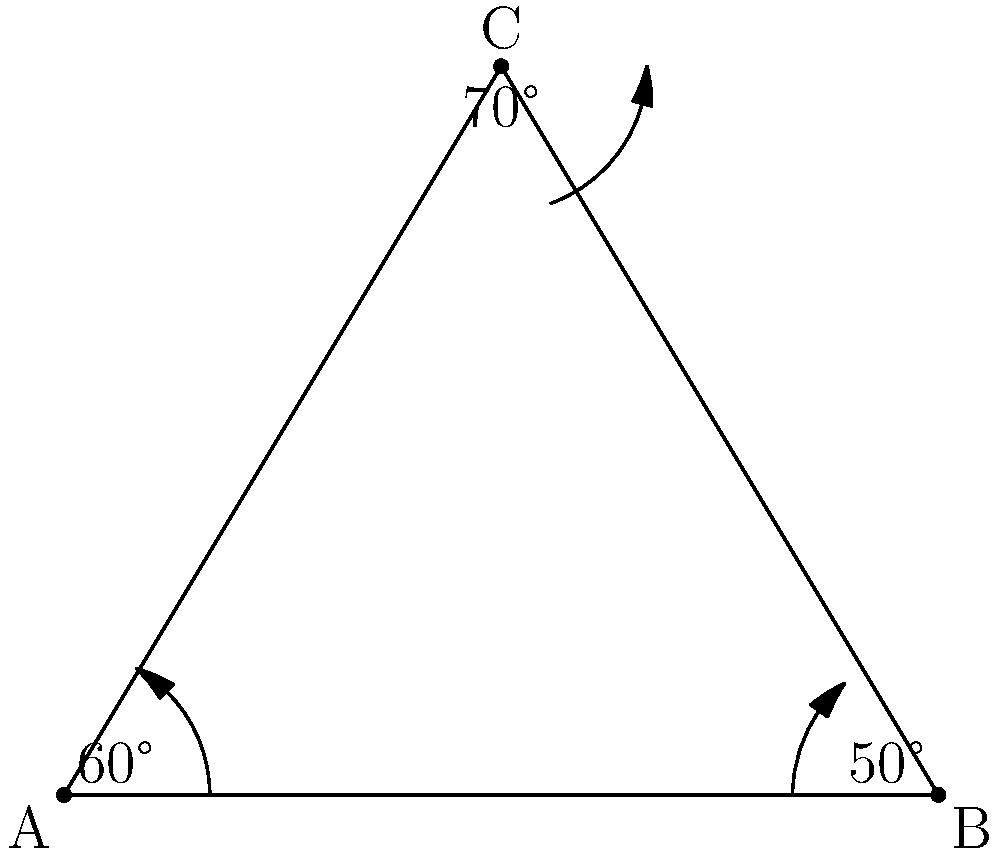In a theater production, three spotlights are positioned to form a triangle on stage. The angles between the spotlights are 60°, 50°, and 70°. If the distance between the two spotlights on the floor is 6 meters, what is the height of the third spotlight above the stage floor? Round your answer to the nearest centimeter. Let's approach this step-by-step:

1) First, we recognize that we have a triangle where all angles are known:
   60° + 50° + 70° = 180°

2) We also know one side length (the base) is 6 meters.

3) We can use the sine rule to find the height. Let's call the height h.

4) The sine rule states: $\frac{a}{\sin A} = \frac{b}{\sin B} = \frac{c}{\sin C}$

5) In our case: $\frac{6}{\sin 70°} = \frac{h}{\sin 60°}$

6) Rearranging this equation:
   $h = \frac{6 \sin 60°}{\sin 70°}$

7) Now let's calculate:
   $h = \frac{6 \cdot \frac{\sqrt{3}}{2}}{\sin 70°}$

8) Using a calculator (or approximate values):
   $h \approx \frac{6 \cdot 0.866}{0.9397} \approx 5.53$ meters

9) Rounding to the nearest centimeter:
   $h \approx 5.53$ meters = 553 centimeters

This height would ensure optimal coverage given the angles between the spotlights.
Answer: 553 cm 